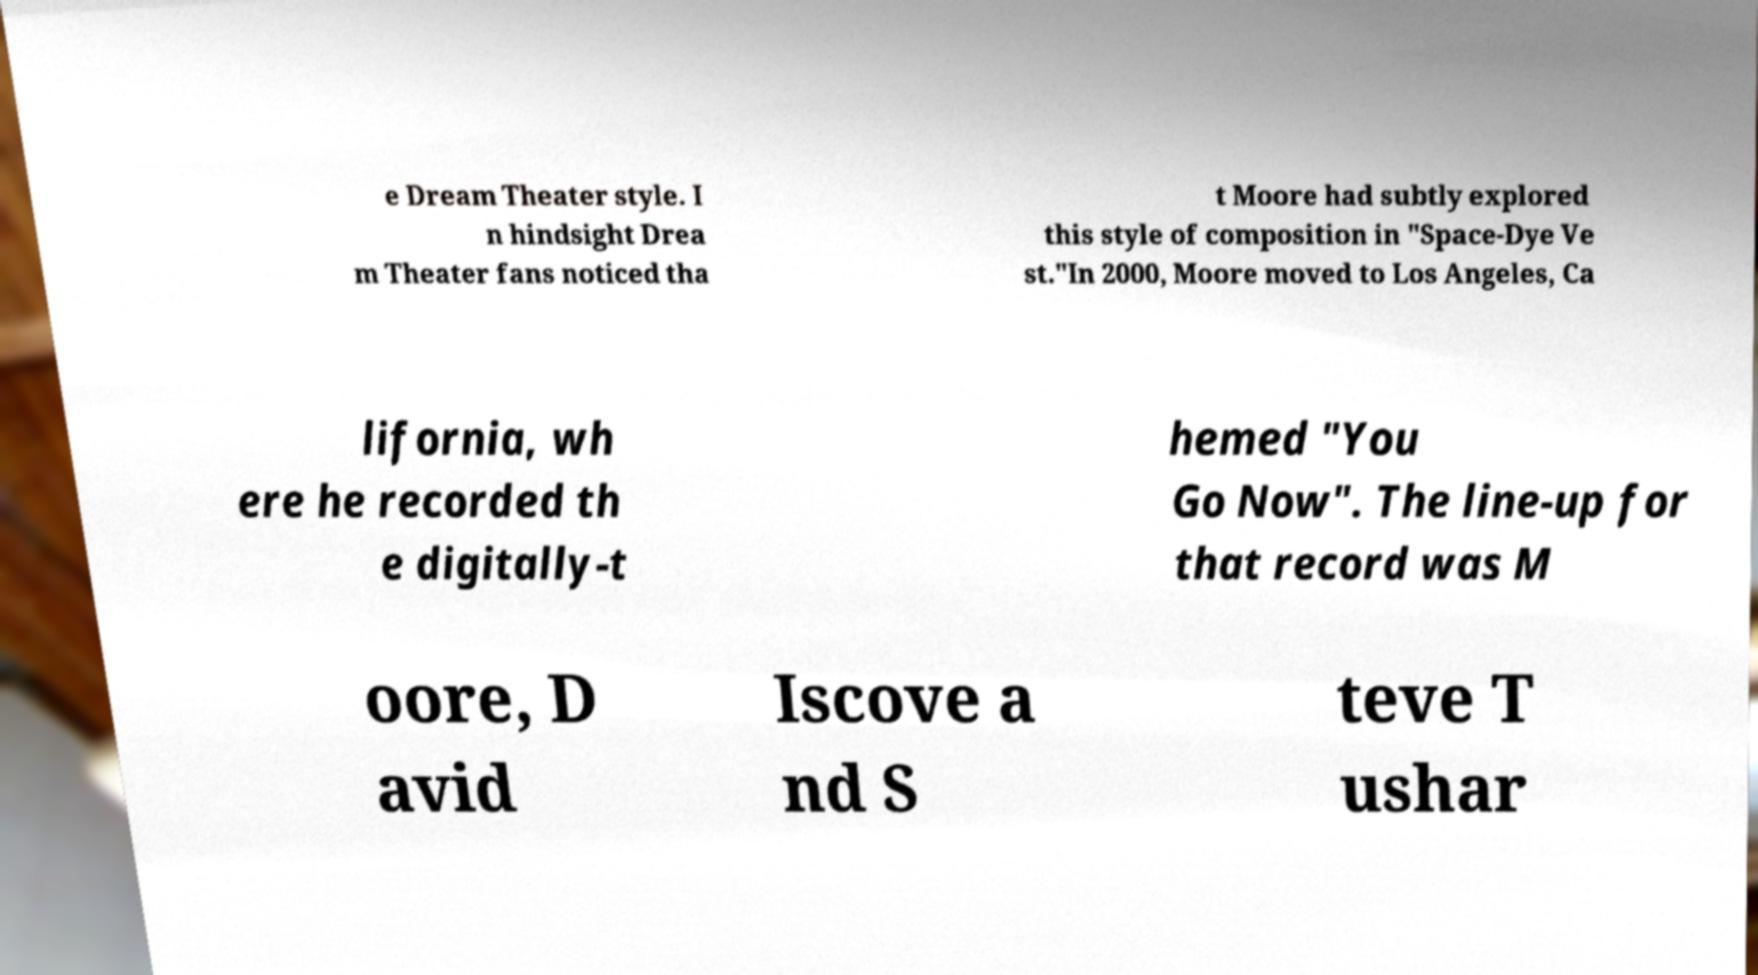Please read and relay the text visible in this image. What does it say? e Dream Theater style. I n hindsight Drea m Theater fans noticed tha t Moore had subtly explored this style of composition in "Space-Dye Ve st."In 2000, Moore moved to Los Angeles, Ca lifornia, wh ere he recorded th e digitally-t hemed "You Go Now". The line-up for that record was M oore, D avid Iscove a nd S teve T ushar 